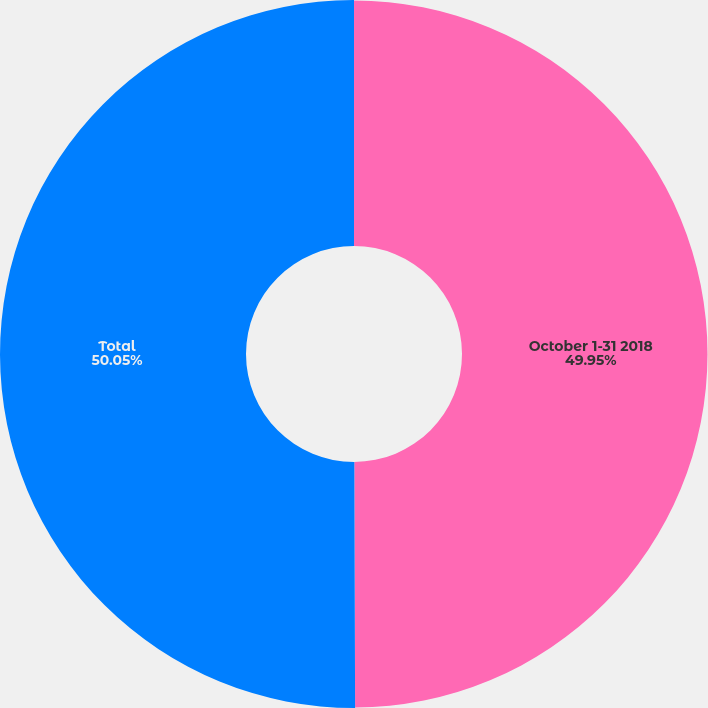<chart> <loc_0><loc_0><loc_500><loc_500><pie_chart><fcel>October 1-31 2018<fcel>Total<nl><fcel>49.95%<fcel>50.05%<nl></chart> 